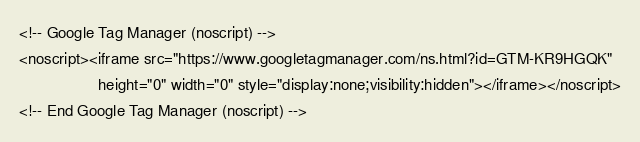Convert code to text. <code><loc_0><loc_0><loc_500><loc_500><_PHP_><!-- Google Tag Manager (noscript) -->
<noscript><iframe src="https://www.googletagmanager.com/ns.html?id=GTM-KR9HGQK"
                  height="0" width="0" style="display:none;visibility:hidden"></iframe></noscript>
<!-- End Google Tag Manager (noscript) -->
</code> 